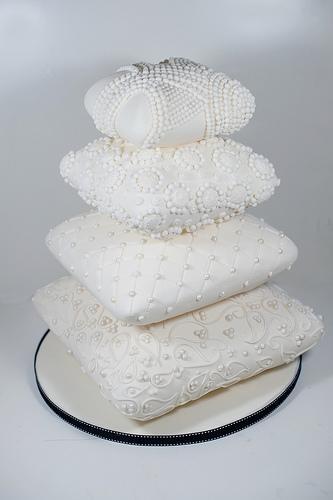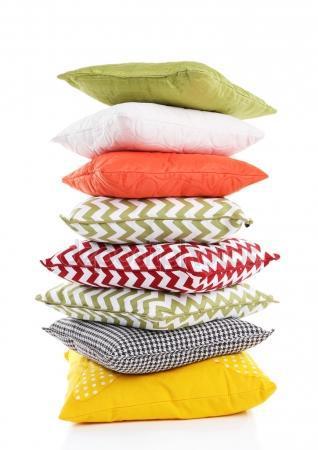The first image is the image on the left, the second image is the image on the right. Analyze the images presented: Is the assertion "In one of the images, there are exactly six square pillows stacked on top of each other." valid? Answer yes or no. No. The first image is the image on the left, the second image is the image on the right. Examine the images to the left and right. Is the description "The left image includes at least one square pillow with a dimensional embellishment, and the right image includes a stack of solid and patterned pillows." accurate? Answer yes or no. Yes. 